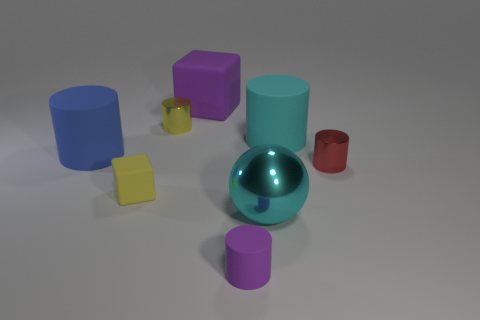Subtract 1 cylinders. How many cylinders are left? 4 Subtract all large blue cylinders. How many cylinders are left? 4 Subtract all yellow cylinders. How many cylinders are left? 4 Add 1 large cyan metal balls. How many objects exist? 9 Subtract all purple cylinders. Subtract all red spheres. How many cylinders are left? 4 Subtract all spheres. How many objects are left? 7 Subtract all large green cylinders. Subtract all red metallic cylinders. How many objects are left? 7 Add 3 metal objects. How many metal objects are left? 6 Add 4 big cyan metal spheres. How many big cyan metal spheres exist? 5 Subtract 0 purple balls. How many objects are left? 8 